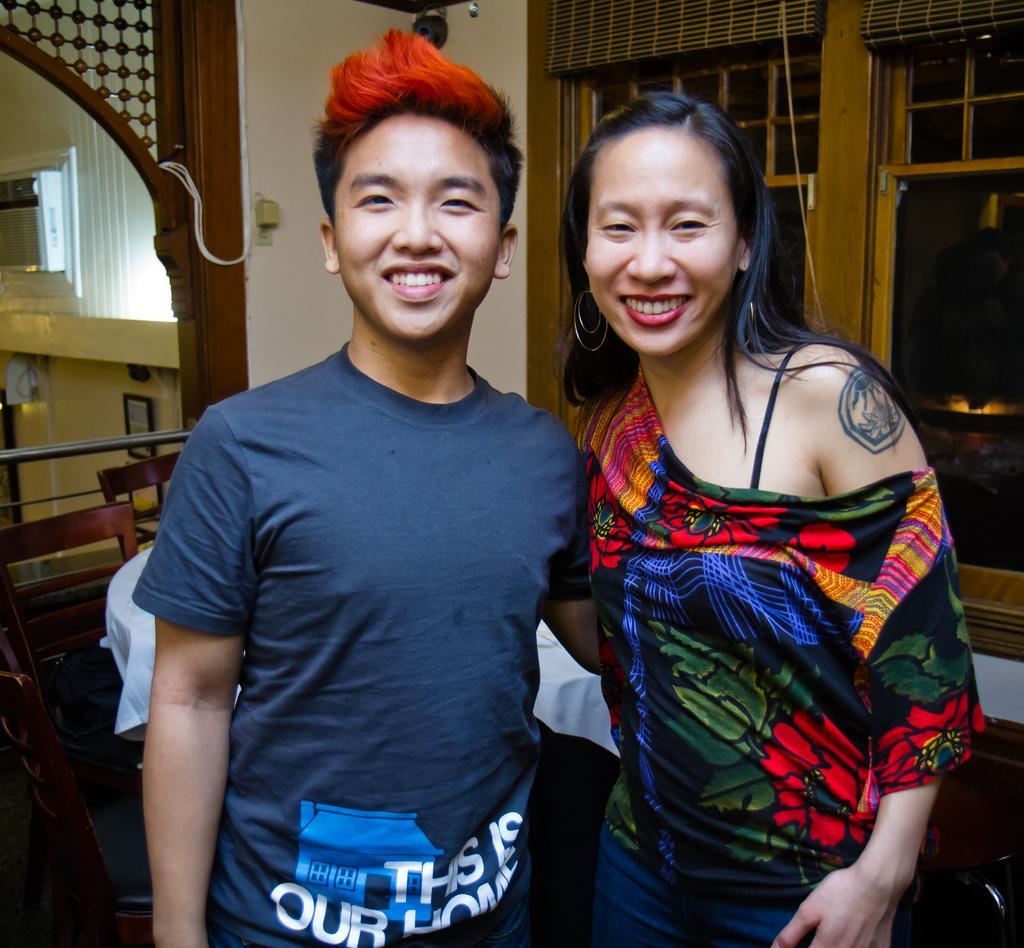Could you give a brief overview of what you see in this image? In this image I can see a person wearing blue colored t shirt and a woman wearing black, green, red and orange colored dress are standing and smiling. In the background I can see a table, white colored cloth on it and few chairs around the table. I can see the wall, few windows and few other objects in the background. 